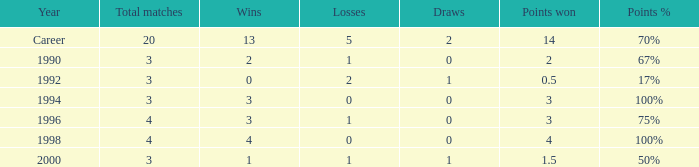Can you tell me the lowest Points won that has the Total matches of 4, and the Total W-L-H of 4-0-0? 4.0. 